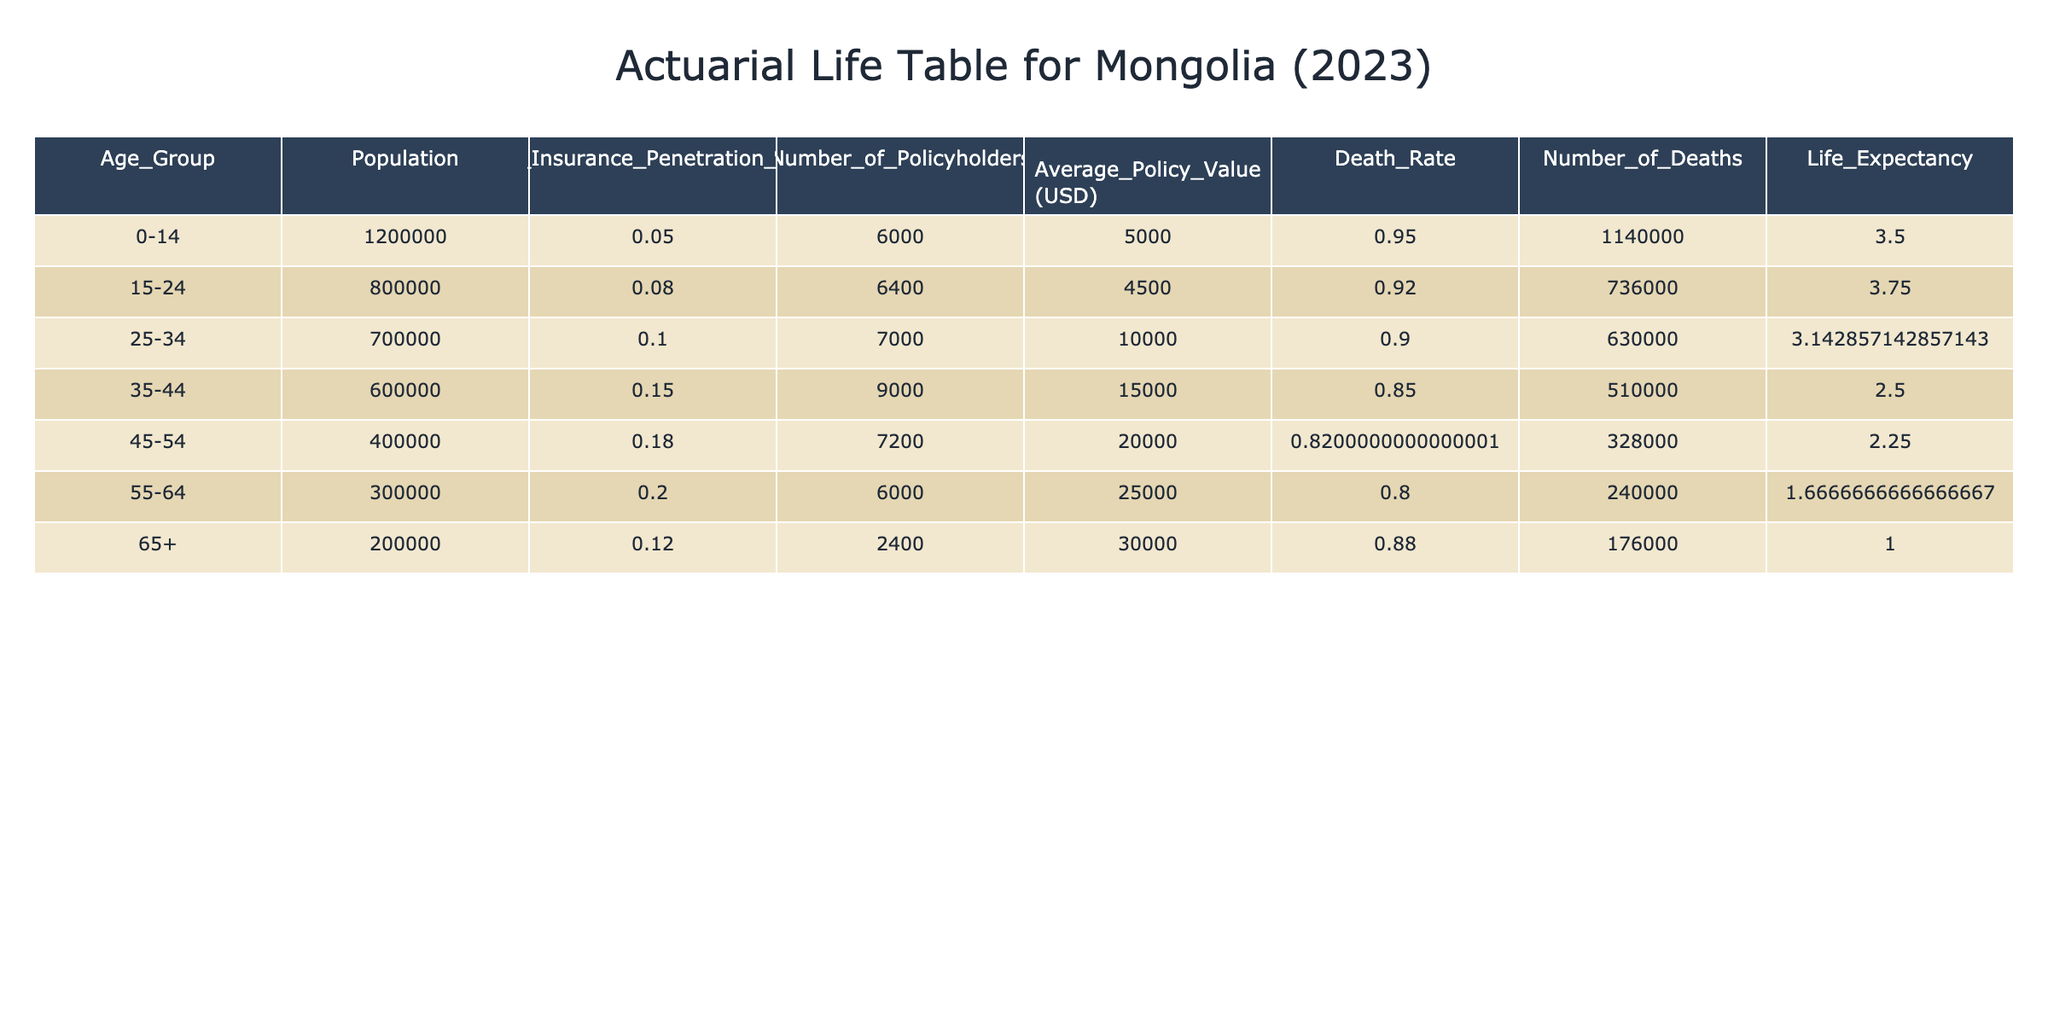What is the life insurance penetration rate for the age group 35-44? From the table, we can find the value directly under the "Life_Insurance_Penetration_Rate" column for the age group 35-44, which is 0.15.
Answer: 0.15 How many policyholders are there in the 45-54 age group? The table states that the number of policyholders for the age group 45-54 is 7200.
Answer: 7200 What is the average policy value for the 25-34 age group? Referring to the table, the average policy value for the age group 25-34 is listed as 10000 USD.
Answer: 10000 USD What is the total number of policyholders across all age groups? We calculate the total by summing the "Number_of_Policyholders" for all age groups: 6000 + 6400 + 7000 + 9000 + 7200 + 6000 + 2400 = 39600.
Answer: 39600 Is the life insurance penetration rate for the age group 0-14 higher than that for age group 65+? The life insurance penetration rate for age group 0-14 is 0.05, while for age group 65+, it is 0.12. Since 0.05 is less than 0.12, the statement is false.
Answer: No What is the number of deaths in the 55-64 age group? The "Number_of_Deaths" for the age group 55-64 can be calculated by using the formula: Population * Death_Rate. The Death_Rate is 1 - Life_Insurance_Penetration_Rate = 1 - 0.20 = 0.80. Thus, it is 300000 * 0.80 = 240000.
Answer: 240000 How does the average policy value for the 15-24 age group compare to the average policy value for the 45-54 age group? The average policy value for the 15-24 age group is 4500 USD, and for the 45-54 age group, it is 20000 USD. Since 4500 is significantly less than 20000, we conclude that the latter has a higher average value.
Answer: Higher for 45-54 What is the average life expectancy across all age groups? To find the average life expectancy, we would sum the life expectancies of all age groups based on the calculations in the table and divide by the number of age groups. This requires finding the cumulative number of individuals divided by their population in each age group. Therefore, we would perform a detailed computation using the values provided.
Answer: Calculation required What is the total population covered under life insurance? To determine the total population covered, we can multiply the total population by the respective penetration rate and sum it across all age groups: (1200000 * 0.05) + (800000 * 0.08) + (700000 * 0.10) + (600000 * 0.15) + (400000 * 0.18) + (300000 * 0.20) + (200000 * 0.12) = 216000.
Answer: 216000 